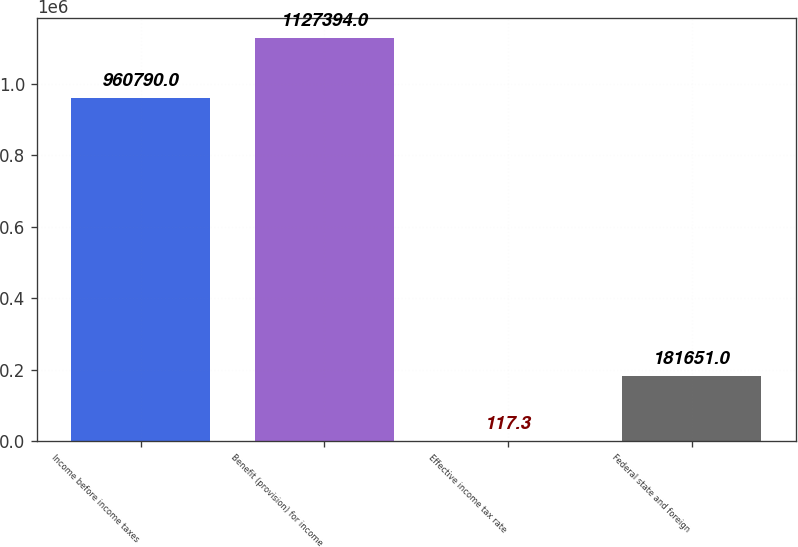Convert chart to OTSL. <chart><loc_0><loc_0><loc_500><loc_500><bar_chart><fcel>Income before income taxes<fcel>Benefit (provision) for income<fcel>Effective income tax rate<fcel>Federal state and foreign<nl><fcel>960790<fcel>1.12739e+06<fcel>117.3<fcel>181651<nl></chart> 